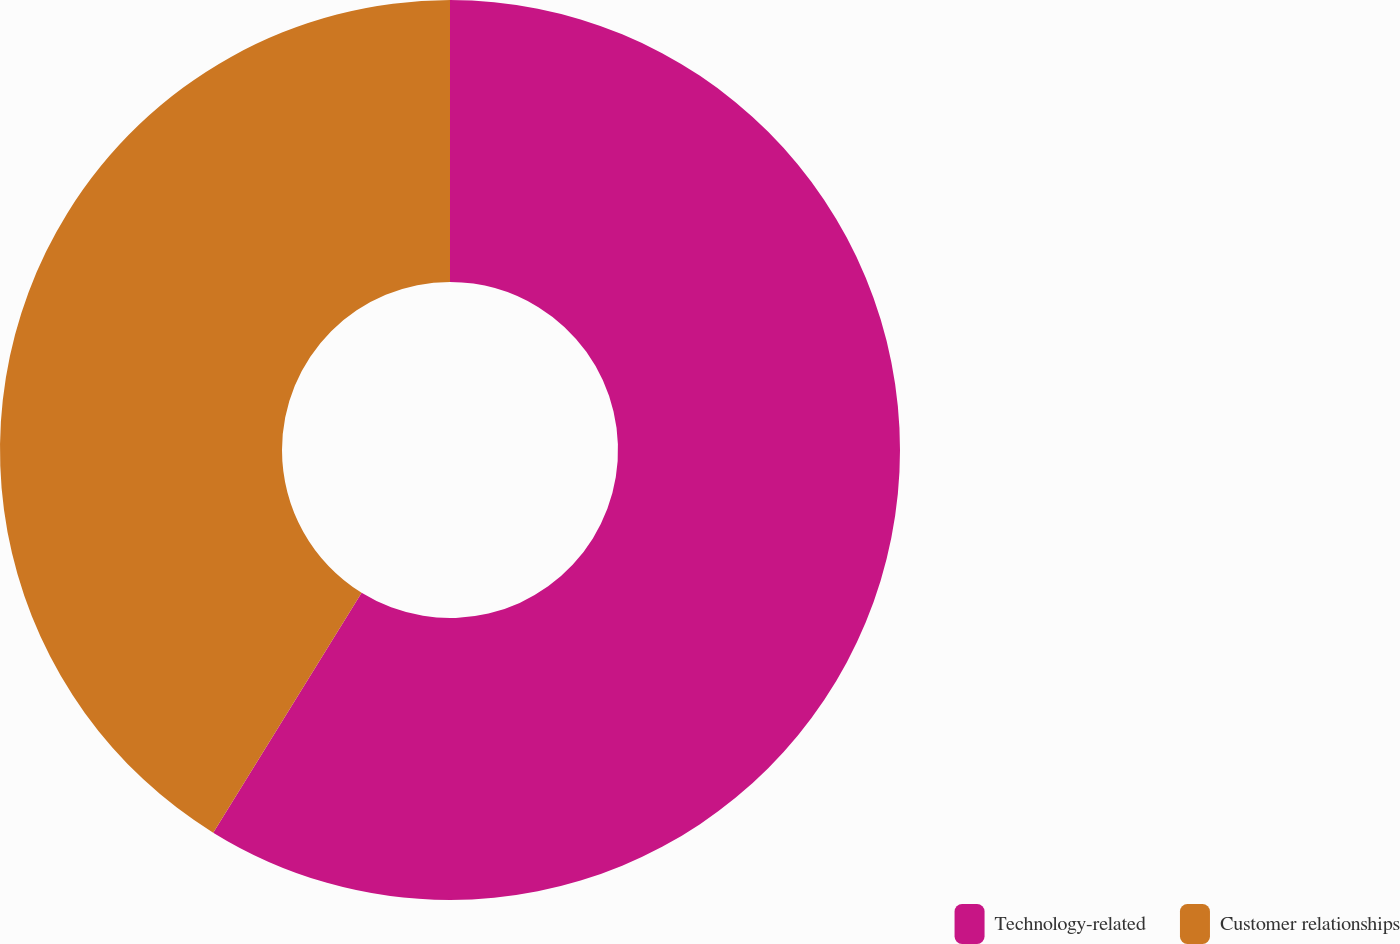Convert chart. <chart><loc_0><loc_0><loc_500><loc_500><pie_chart><fcel>Technology-related<fcel>Customer relationships<nl><fcel>58.82%<fcel>41.18%<nl></chart> 